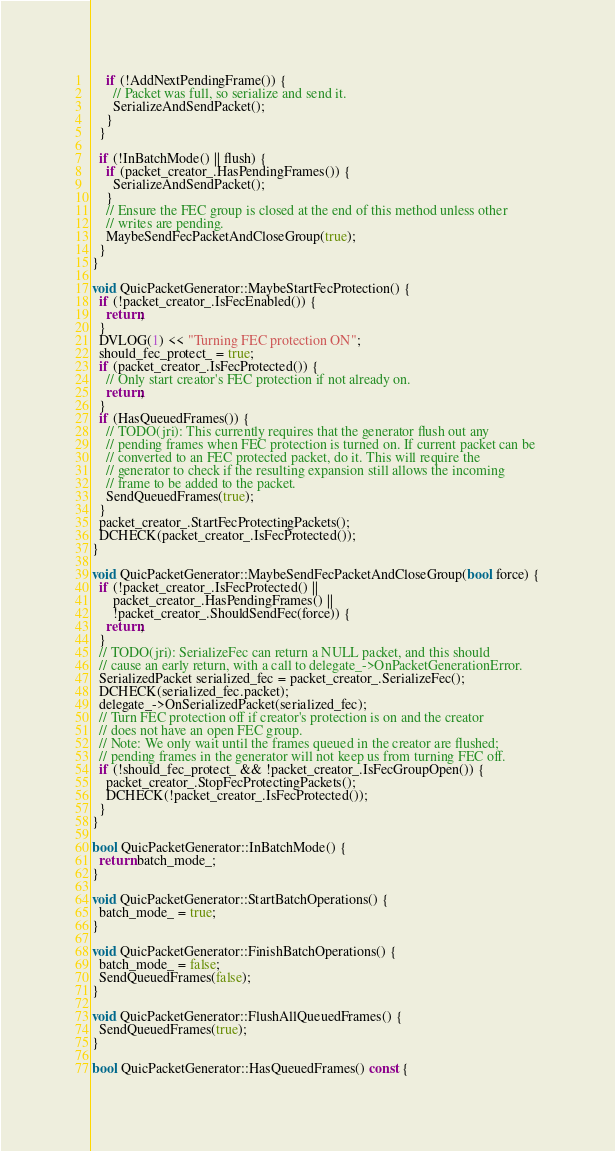Convert code to text. <code><loc_0><loc_0><loc_500><loc_500><_C++_>    if (!AddNextPendingFrame()) {
      // Packet was full, so serialize and send it.
      SerializeAndSendPacket();
    }
  }

  if (!InBatchMode() || flush) {
    if (packet_creator_.HasPendingFrames()) {
      SerializeAndSendPacket();
    }
    // Ensure the FEC group is closed at the end of this method unless other
    // writes are pending.
    MaybeSendFecPacketAndCloseGroup(true);
  }
}

void QuicPacketGenerator::MaybeStartFecProtection() {
  if (!packet_creator_.IsFecEnabled()) {
    return;
  }
  DVLOG(1) << "Turning FEC protection ON";
  should_fec_protect_ = true;
  if (packet_creator_.IsFecProtected()) {
    // Only start creator's FEC protection if not already on.
    return;
  }
  if (HasQueuedFrames()) {
    // TODO(jri): This currently requires that the generator flush out any
    // pending frames when FEC protection is turned on. If current packet can be
    // converted to an FEC protected packet, do it. This will require the
    // generator to check if the resulting expansion still allows the incoming
    // frame to be added to the packet.
    SendQueuedFrames(true);
  }
  packet_creator_.StartFecProtectingPackets();
  DCHECK(packet_creator_.IsFecProtected());
}

void QuicPacketGenerator::MaybeSendFecPacketAndCloseGroup(bool force) {
  if (!packet_creator_.IsFecProtected() ||
      packet_creator_.HasPendingFrames() ||
      !packet_creator_.ShouldSendFec(force)) {
    return;
  }
  // TODO(jri): SerializeFec can return a NULL packet, and this should
  // cause an early return, with a call to delegate_->OnPacketGenerationError.
  SerializedPacket serialized_fec = packet_creator_.SerializeFec();
  DCHECK(serialized_fec.packet);
  delegate_->OnSerializedPacket(serialized_fec);
  // Turn FEC protection off if creator's protection is on and the creator
  // does not have an open FEC group.
  // Note: We only wait until the frames queued in the creator are flushed;
  // pending frames in the generator will not keep us from turning FEC off.
  if (!should_fec_protect_ && !packet_creator_.IsFecGroupOpen()) {
    packet_creator_.StopFecProtectingPackets();
    DCHECK(!packet_creator_.IsFecProtected());
  }
}

bool QuicPacketGenerator::InBatchMode() {
  return batch_mode_;
}

void QuicPacketGenerator::StartBatchOperations() {
  batch_mode_ = true;
}

void QuicPacketGenerator::FinishBatchOperations() {
  batch_mode_ = false;
  SendQueuedFrames(false);
}

void QuicPacketGenerator::FlushAllQueuedFrames() {
  SendQueuedFrames(true);
}

bool QuicPacketGenerator::HasQueuedFrames() const {</code> 